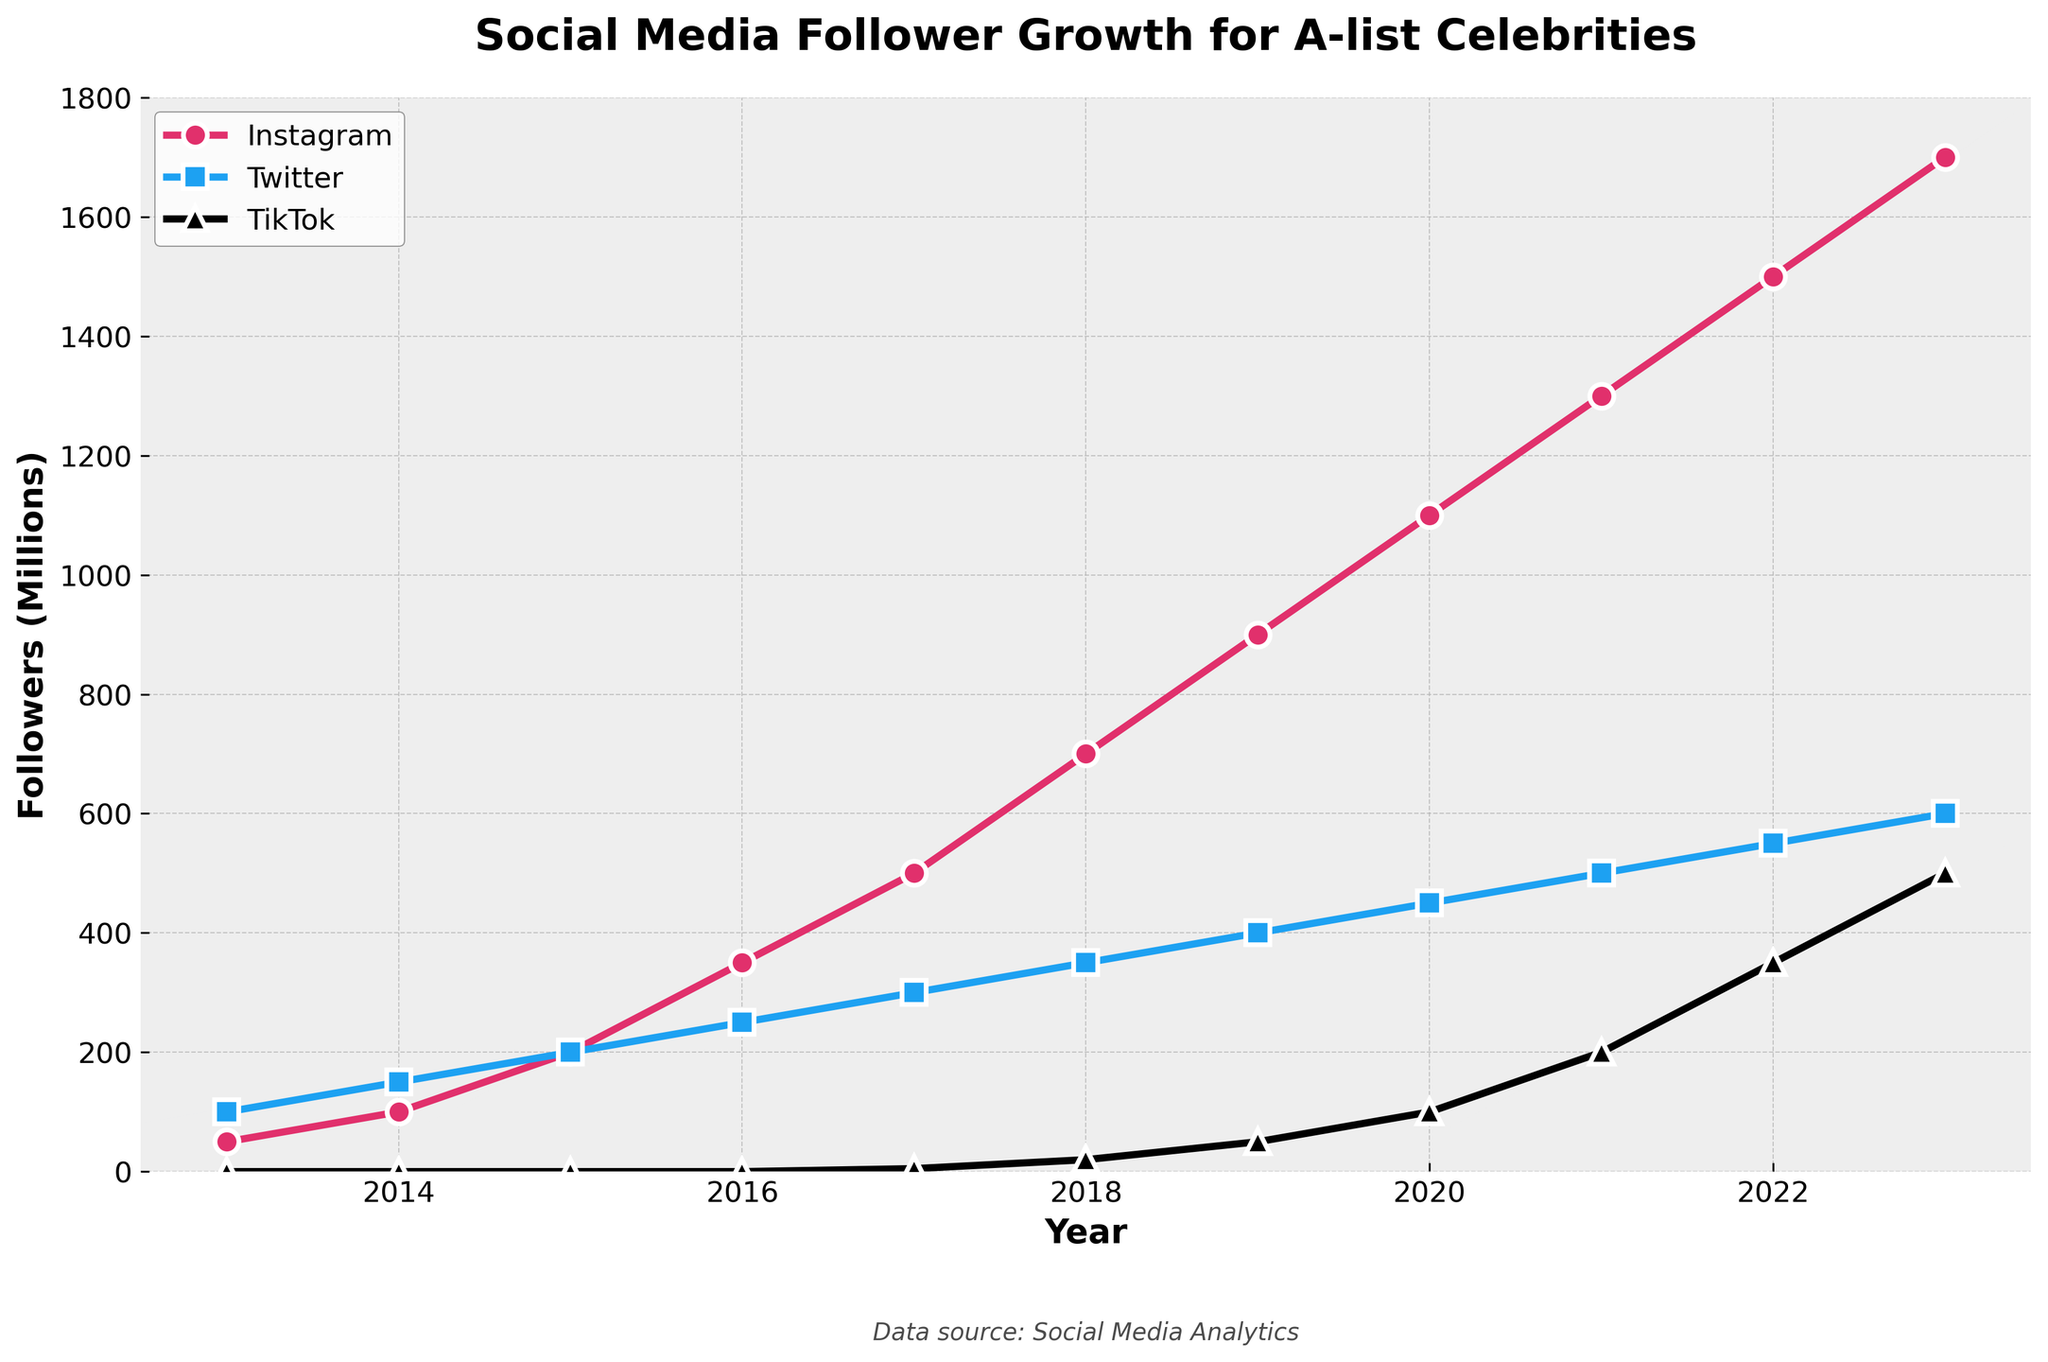What year did Instagram surpass Twitter in followers? In 2015, Instagram had 200 million followers and Twitter had 200 million followers as well. Starting from 2016, Instagram had more followers each year compared to Twitter. Therefore, Instagram surpassed Twitter in 2016.
Answer: 2016 Which platform had the most significant growth spurt over the entire decade? To determine this, we look at the slope or steepness of the lines in the graph. Instagram's line shows the steepest increase, gaining from 50 million in 2013 to 1700 million in 2023, which is a 1650 million increase. Twitter grew by 500 million (100 to 600 million), and TikTok grew by 500 million but started from 0 in 2013. Therefore, Instagram had the most significant growth spurt.
Answer: Instagram What was the total number of followers across all platforms in 2020? In 2020, Instagram had 1100 million followers, Twitter had 450 million followers, and TikTok had 100 million followers. Summing these up gives 1100 + 450 + 100 = 1650 million followers.
Answer: 1650 million Between which two consecutive years did TikTok see the largest increase in followers? To find this, we check the differences between consecutive years for TikTok followers: 2017-2018 (20 - 5 = 15 million), 2018-2019 (50 - 20 = 30 million), 2019-2020 (100 - 50 = 50 million), 2020-2021 (200 - 100 = 100 million), 2021-2022 (350 - 200 = 150 million), 2022-2023 (500 - 350 = 150 million). The largest increase of 150 million occurred between both 2021-2022 and 2022-2023.
Answer: 2021-2022 and 2022-2023 How does the follower growth on TikTok in its initial year (2017) compare to its growth in 2023? In 2017, TikTok had 5 million followers. By 2023, TikTok had 500 million followers, showing a considerable increase. The growth in 2023 compared to 2017 represents an increase of 495 million followers (500 - 5).
Answer: 495 million What is the total increase in Instagram followers from 2013 to 2023? In 2013, Instagram had 50 million followers. In 2023, it had 1700 million followers. The total increase is 1700 - 50 = 1650 million followers.
Answer: 1650 million Which platform reached 500 million followers first, and in what year? By inspecting the graph, we observe that Twitter reached 500 million followers in 2021 and Instagram reached it in 2017. TikTok had not reached 500 million followers until 2023. Therefore, Instagram was the first platform to reach this milestone in 2017.
Answer: Instagram, 2017 What was the difference in the number of Instagram followers between 2016 and 2019? Instagram followers in 2016 were 350 million and in 2019 were 900 million. The difference is 900 - 350 = 550 million followers.
Answer: 550 million In which year did all three platforms collectively reach over 1000 million followers? To find this, we sum the followers for all platforms for each year. By 2017, the totals were: 2013 (150 million), 2014 (250 million), 2015 (400 million), 2016 (600 million), 2017 (805 million), 2018 (1070 million). Collectively, they reached over 1000 million in 2018.
Answer: 2018 